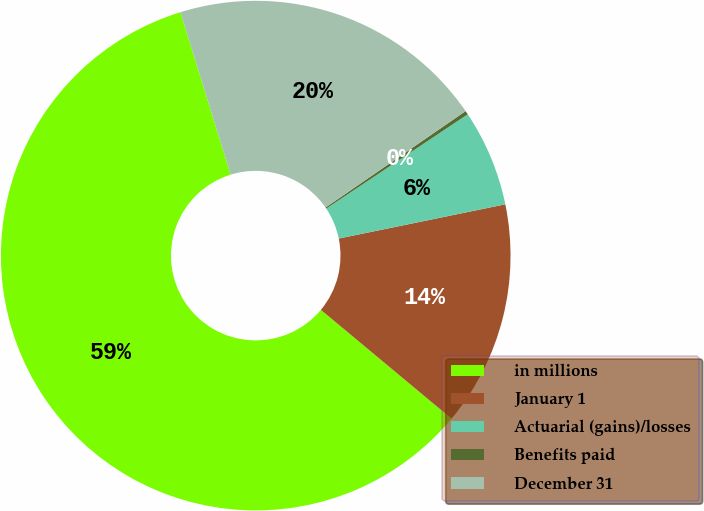Convert chart. <chart><loc_0><loc_0><loc_500><loc_500><pie_chart><fcel>in millions<fcel>January 1<fcel>Actuarial (gains)/losses<fcel>Benefits paid<fcel>December 31<nl><fcel>59.17%<fcel>14.28%<fcel>6.13%<fcel>0.24%<fcel>20.18%<nl></chart> 